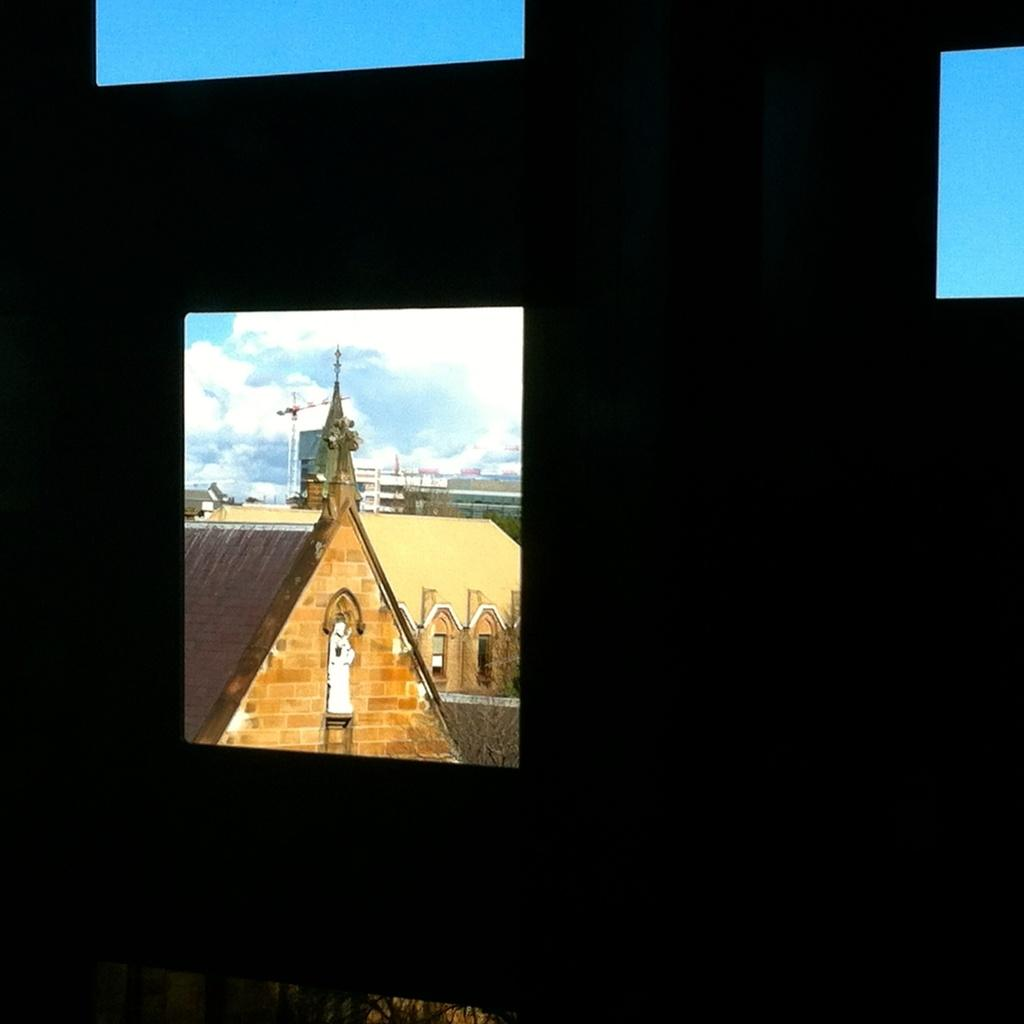What object in the image resembles a window? There is an object in the image that looks like a window. What can be seen through the window? Buildings, trees, and the sky with clouds are visible through the window. Are there any other objects or features near the window? Yes, there is a statue near the building. How many dinosaurs are visible through the window in the image? There are no dinosaurs visible through the window in the image. Can you tell me the species of the owl perched on the statue? There is no owl present in the image. 